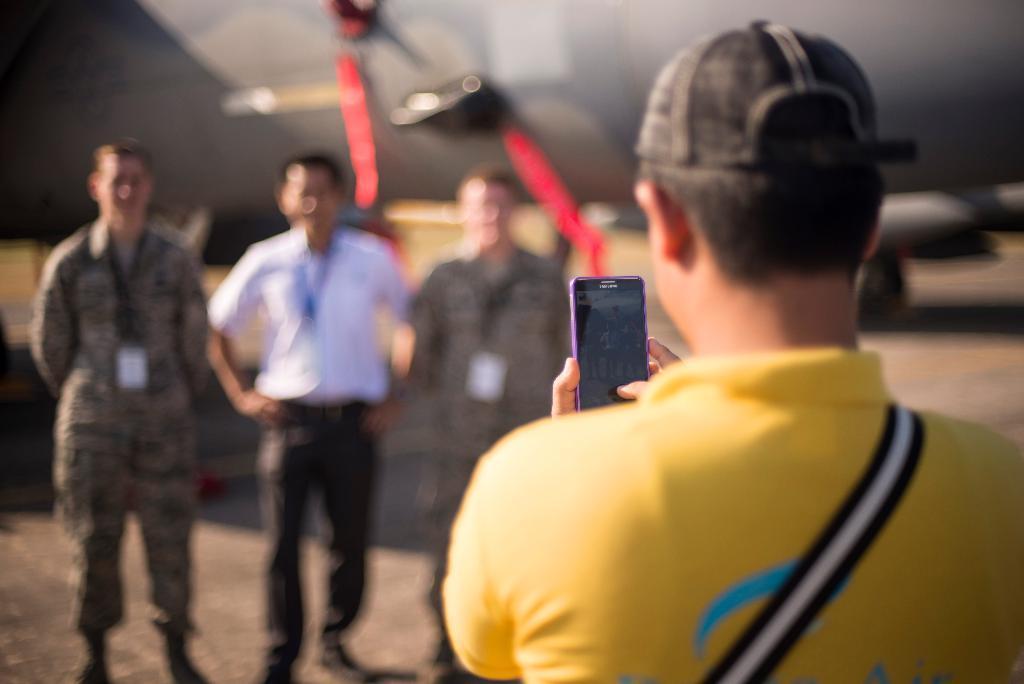Describe this image in one or two sentences. In this image in the right a man wearing a yellow t-shirt and a cap is holding a mobile. He is clicking picture of three persons standing in front of him. there is an aeroplane in the background. 